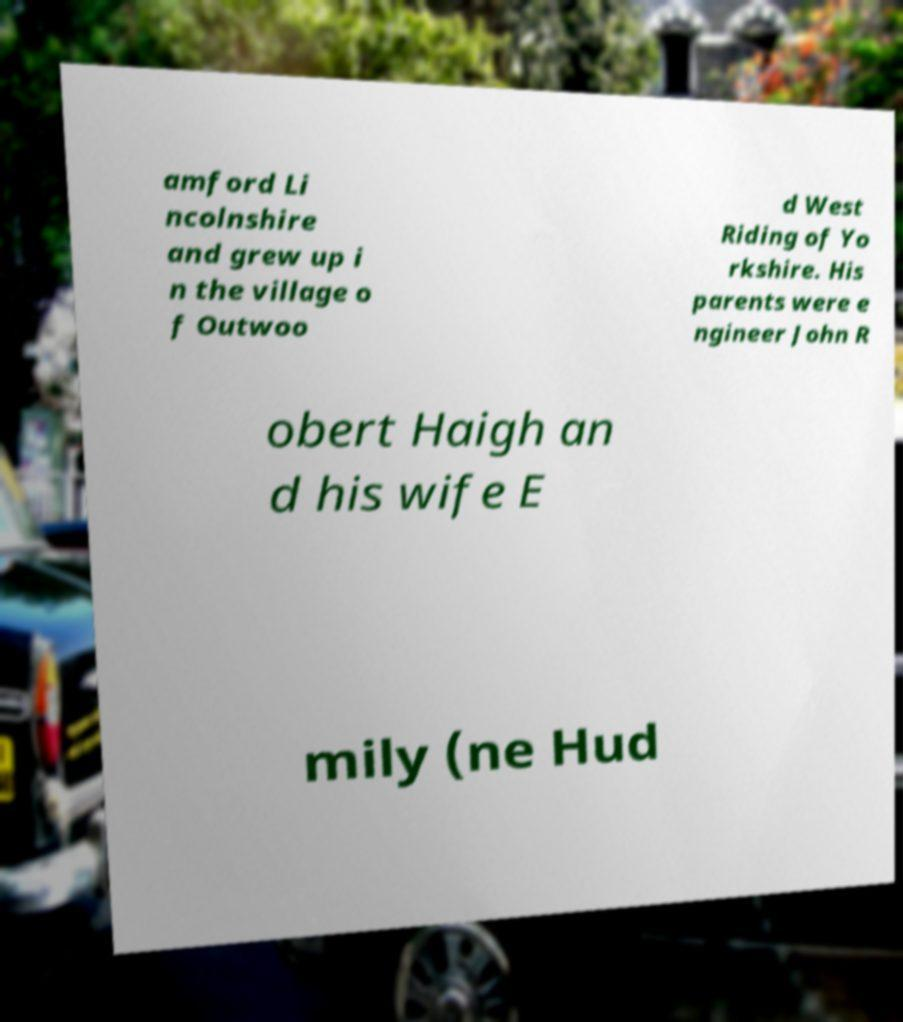There's text embedded in this image that I need extracted. Can you transcribe it verbatim? amford Li ncolnshire and grew up i n the village o f Outwoo d West Riding of Yo rkshire. His parents were e ngineer John R obert Haigh an d his wife E mily (ne Hud 